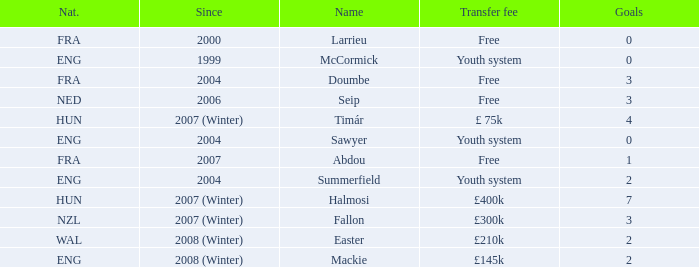Can you give me this table as a dict? {'header': ['Nat.', 'Since', 'Name', 'Transfer fee', 'Goals'], 'rows': [['FRA', '2000', 'Larrieu', 'Free', '0'], ['ENG', '1999', 'McCormick', 'Youth system', '0'], ['FRA', '2004', 'Doumbe', 'Free', '3'], ['NED', '2006', 'Seip', 'Free', '3'], ['HUN', '2007 (Winter)', 'Timár', '£ 75k', '4'], ['ENG', '2004', 'Sawyer', 'Youth system', '0'], ['FRA', '2007', 'Abdou', 'Free', '1'], ['ENG', '2004', 'Summerfield', 'Youth system', '2'], ['HUN', '2007 (Winter)', 'Halmosi', '£400k', '7'], ['NZL', '2007 (Winter)', 'Fallon', '£300k', '3'], ['WAL', '2008 (Winter)', 'Easter', '£210k', '2'], ['ENG', '2008 (Winter)', 'Mackie', '£145k', '2']]} From what year has the player with a £75k transfer fee been active? 2007 (Winter). 